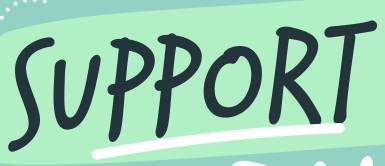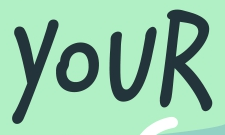Identify the words shown in these images in order, separated by a semicolon. SUPPORT; YOUR 